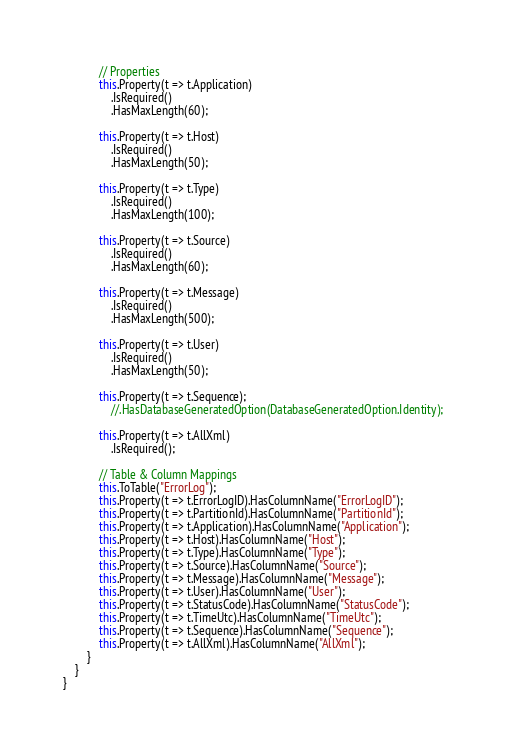<code> <loc_0><loc_0><loc_500><loc_500><_C#_>            // Properties
            this.Property(t => t.Application)
                .IsRequired()
                .HasMaxLength(60);

            this.Property(t => t.Host)
                .IsRequired()
                .HasMaxLength(50);

            this.Property(t => t.Type)
                .IsRequired()
                .HasMaxLength(100);

            this.Property(t => t.Source)
                .IsRequired()
                .HasMaxLength(60);

            this.Property(t => t.Message)
                .IsRequired()
                .HasMaxLength(500);

            this.Property(t => t.User)
                .IsRequired()
                .HasMaxLength(50);

            this.Property(t => t.Sequence);
                //.HasDatabaseGeneratedOption(DatabaseGeneratedOption.Identity);

            this.Property(t => t.AllXml)
                .IsRequired();

            // Table & Column Mappings
            this.ToTable("ErrorLog");
            this.Property(t => t.ErrorLogID).HasColumnName("ErrorLogID");
            this.Property(t => t.PartitionId).HasColumnName("PartitionId");
            this.Property(t => t.Application).HasColumnName("Application");
            this.Property(t => t.Host).HasColumnName("Host");
            this.Property(t => t.Type).HasColumnName("Type");
            this.Property(t => t.Source).HasColumnName("Source");
            this.Property(t => t.Message).HasColumnName("Message");
            this.Property(t => t.User).HasColumnName("User");
            this.Property(t => t.StatusCode).HasColumnName("StatusCode");
            this.Property(t => t.TimeUtc).HasColumnName("TimeUtc");
            this.Property(t => t.Sequence).HasColumnName("Sequence");
            this.Property(t => t.AllXml).HasColumnName("AllXml");
        }
    }
}
</code> 